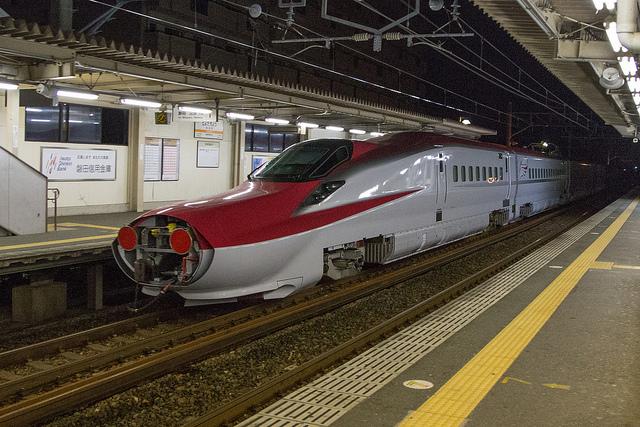How can you tell this train is meant to go fast?
Be succinct. Shape. Is this a subway?
Short answer required. Yes. Is it daytime?
Write a very short answer. No. Is this train for passengers or cargo?
Give a very brief answer. Passengers. What is the color train?
Be succinct. Red, white. How many tracks can be seen?
Quick response, please. 1. Is this a steam engine?
Quick response, please. No. 